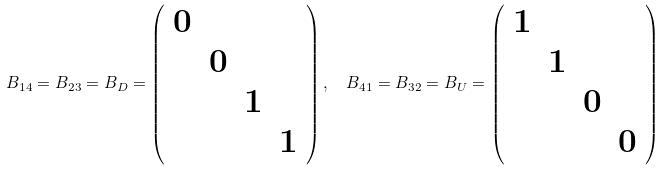<formula> <loc_0><loc_0><loc_500><loc_500>B _ { 1 4 } = B _ { 2 3 } = B _ { D } = \left ( \begin{array} { c c c c } 0 & & & \\ & 0 & & \\ & & 1 & \\ & & & 1 \end{array} \right ) , \ \ B _ { 4 1 } = B _ { 3 2 } = B _ { U } = \left ( \begin{array} { c c c c } 1 & & & \\ & 1 & & \\ & & 0 & \\ & & & 0 \end{array} \right )</formula> 